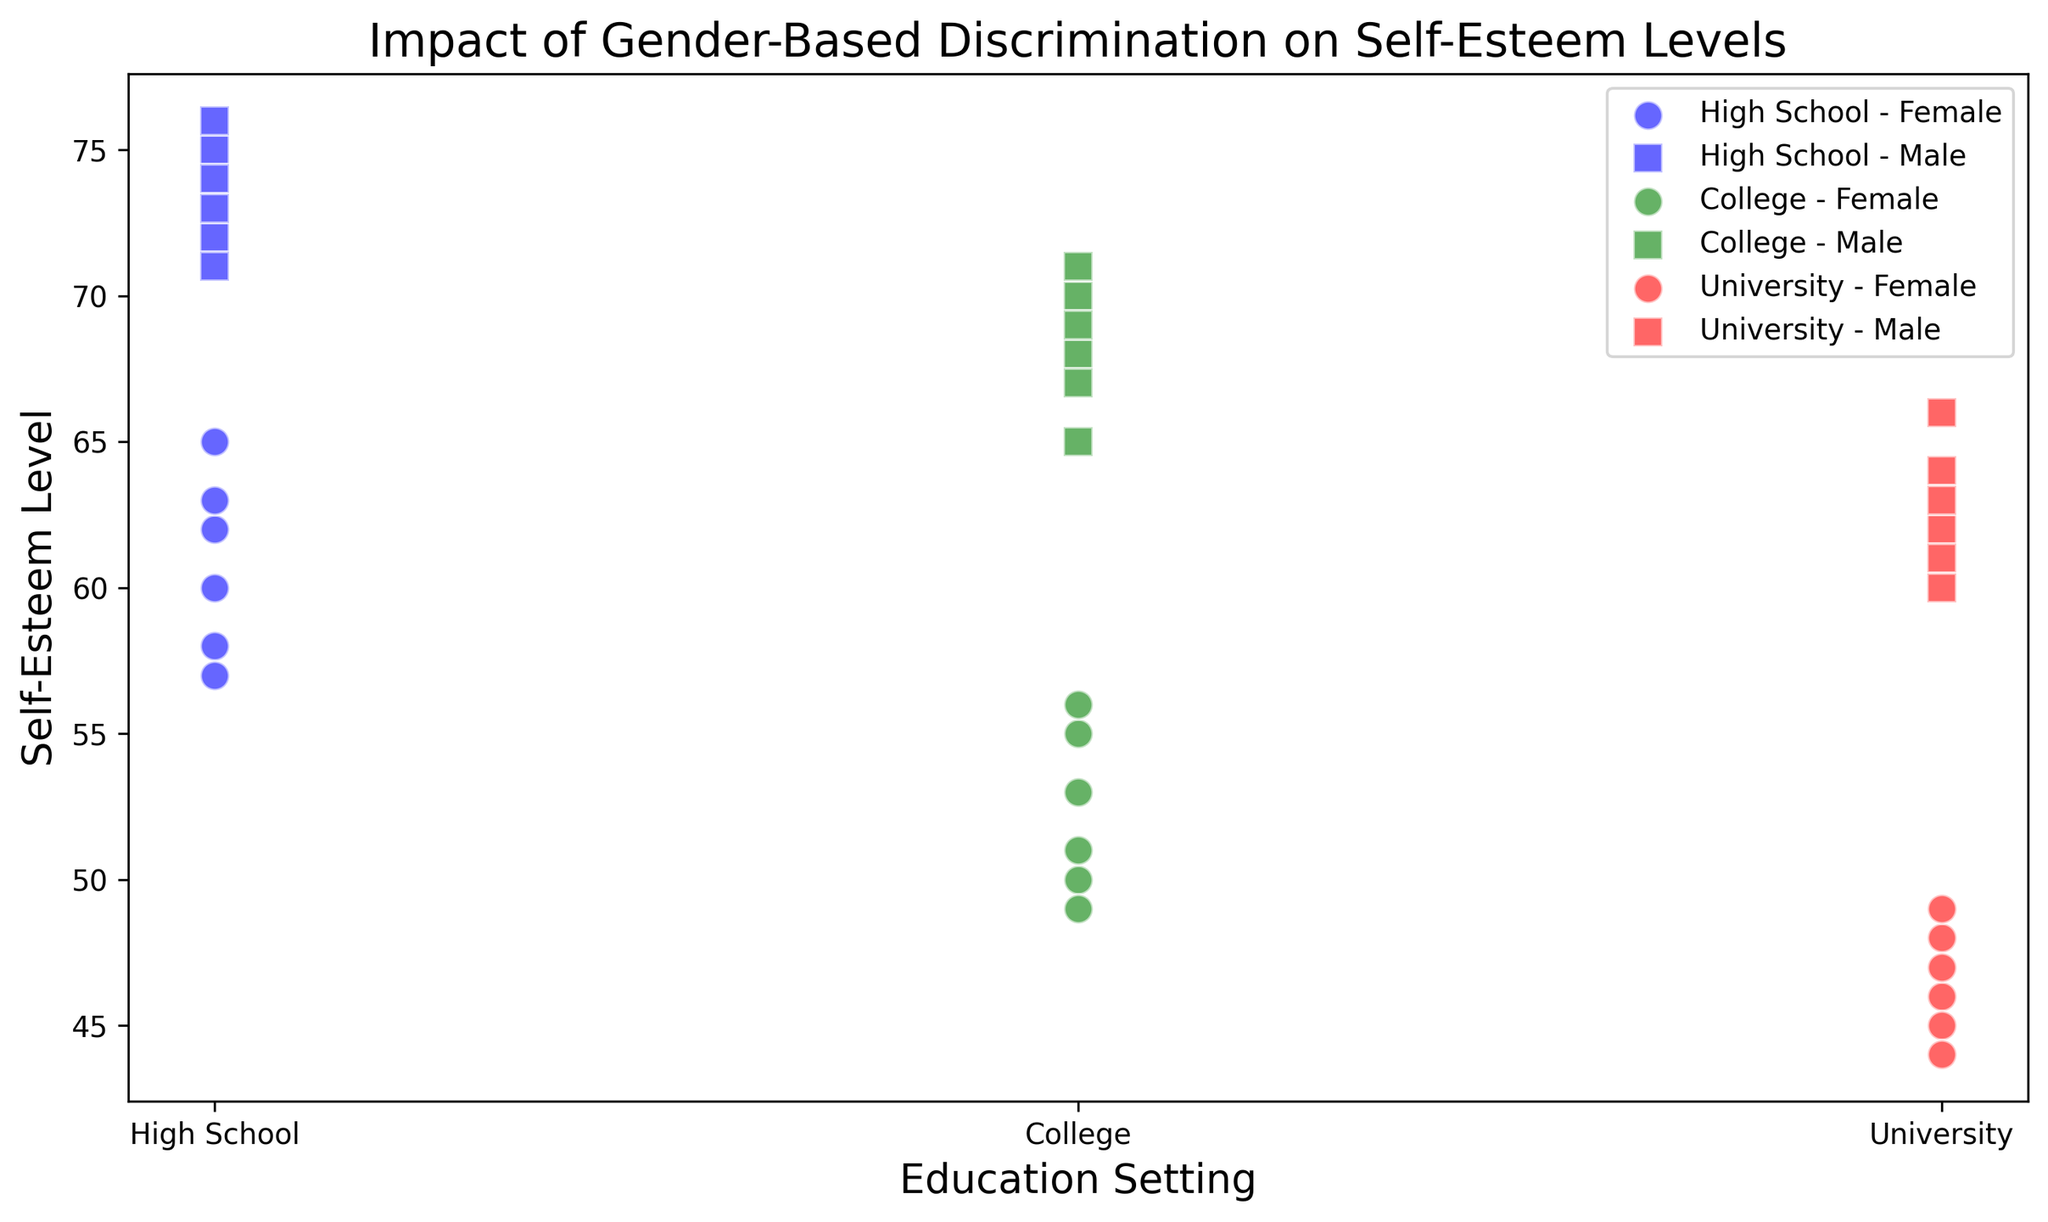What visual patterns do you observe in the self-esteem levels between genders in high school? High school self-esteem levels for females range between 57 and 65, depicted in blue circles. In contrast, males' self-esteem levels are between 71 and 76, shown in blue squares. Males generally have higher self-esteem levels than females in high school.
Answer: Males have higher self-esteem Which education setting shows the smallest gap in self-esteem levels between genders? To find the education setting with the smallest gap, we need to compare the ranges for each setting:
- High School: Female (57-65), Male (71-76) -> Gap = 76 - 57 = 19
- College: Female (49-56), Male (65-71) -> Gap = 71 - 49 = 22
- University: Female (44-49), Male (60-66) -> Gap = 66 - 44 = 22
High School has the smallest gap of 19.
Answer: High School Which group shows the highest self-esteem level overall, and what is that level? The highest self-esteem level is represented by the scatter plot points. By inspecting the figure, the males in high school possess the highest self-esteem levels (shown as blue squares), reaching up to 76.
Answer: High school males, 76 How do the self-esteem levels of females change across education settings? Inspecting the scatter plot for blue circles (High School), green circles (College), and red circles (University):
- High School: 57 to 65
- College: 49 to 56
- University: 44 to 49
There is a consistent decline in self-esteem levels as the education setting progresses.
Answer: They decline What is the average self-esteem level for females in college? The self-esteem levels for females in college are 55, 50, 53, 49, 56, and 51. Sum these values: 55 + 50 + 53 + 49 + 56 + 51 = 314. Divide by the number of data points (6): 314 / 6 ≈ 52.33.
Answer: 52.33 Compare the spread of self-esteem levels for males in college versus males in university. To compare the spread:
- College: 65 to 71 (Range = 71 - 65 = 6)
- University: 60 to 66 (Range = 66 - 60 = 6)
Both groups have the same spread or range of self-esteem levels.
Answer: Same spread How does the self-esteem level of females in universities compare to that of males in universities? Inspecting the scatter plot for red circles (females) and red squares (males):
- Females: 44 to 49
- Males: 60 to 66
Males have consistently higher self-esteem levels at the university level.
Answer: Males are higher For males in each education setting, which setting has the highest median self-esteem level? The median is the middle value in the ordered data set.
- High School: 71, 72, 73, 74, 75, 76 -> Median = (73+74)/2 = 73.5
- College: 65, 67, 68, 69, 70, 71 -> Median = (68+69)/2 = 68.5
- University: 60, 61, 62, 63, 64, 66 -> Median = (62+63)/2 = 62.5
High School has the highest median self-esteem level for males.
Answer: High School Which education setting for females shows the highest variation in self-esteem levels? Variation can be assessed by the range (difference between the highest and lowest values).
- High School: 57 to 65 (Range = 8)
- College: 49 to 56 (Range = 7)
- University: 44 to 49 (Range = 5)
High School has the highest variation in self-esteem levels for females.
Answer: High School 